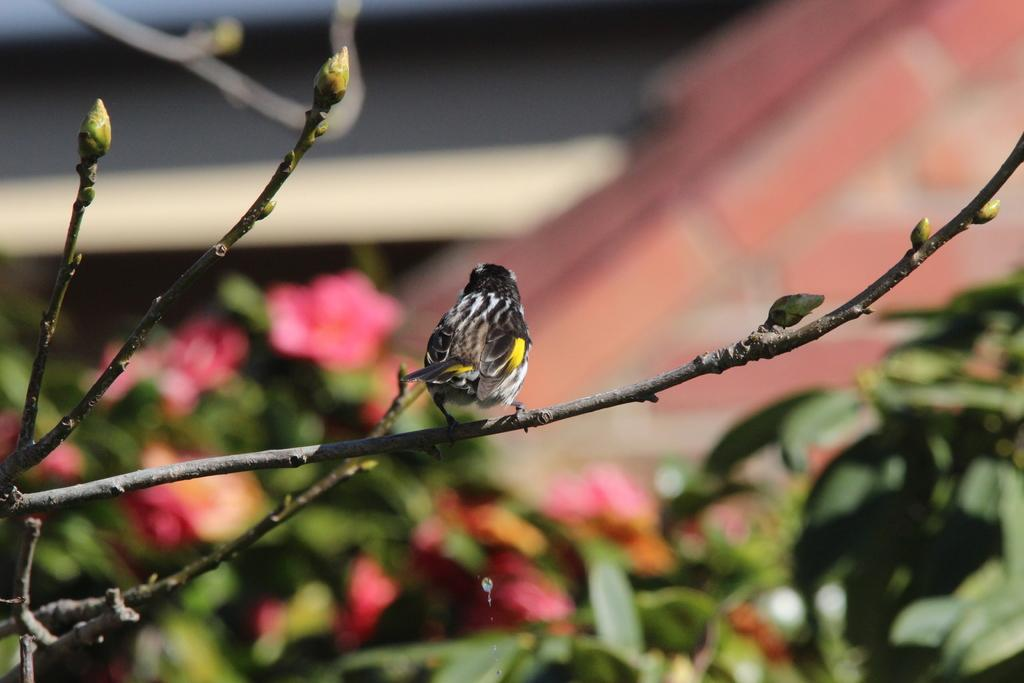What type of animal can be seen in the image? There is a bird in the image. Where is the bird located? The bird is on a branch. What can be seen in the image besides the bird? There are buds, plants, and flowers in the image. How would you describe the background of the image? The background of the image is blurred. What type of string is the bird using to hold its lunch in the image? There is no string or lunch present in the image; it only features a bird on a branch with buds, plants, and flowers. 